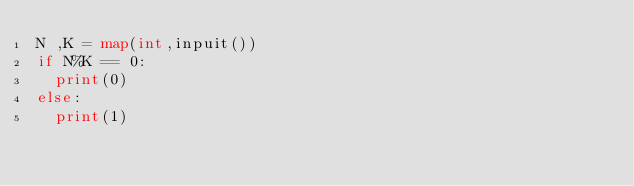<code> <loc_0><loc_0><loc_500><loc_500><_Python_>N ,K = map(int,inpuit())
if N%K == 0:
  print(0)
else:
  print(1)
</code> 